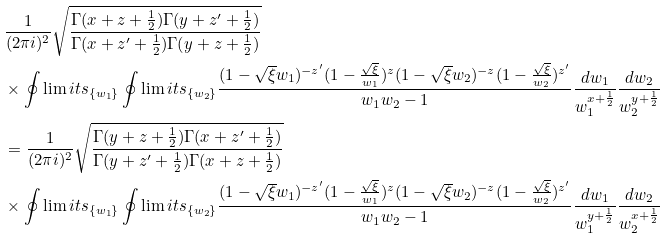Convert formula to latex. <formula><loc_0><loc_0><loc_500><loc_500>& \frac { 1 } { ( 2 \pi i ) ^ { 2 } } \sqrt { \frac { \Gamma ( x + z + \frac { 1 } { 2 } ) \Gamma ( y + z ^ { \prime } + \frac { 1 } { 2 } ) } { \Gamma ( x + z ^ { \prime } + \frac { 1 } { 2 } ) \Gamma ( y + z + \frac { 1 } { 2 } ) } } \\ & \times \oint \lim i t s _ { \{ w _ { 1 } \} } \oint \lim i t s _ { \{ w _ { 2 } \} } \frac { ( 1 - \sqrt { \xi } w _ { 1 } ) ^ { - z ^ { \prime } } ( 1 - \frac { \sqrt { \xi } } { w _ { 1 } } ) ^ { z } ( 1 - \sqrt { \xi } w _ { 2 } ) ^ { - z } ( 1 - \frac { \sqrt { \xi } } { w _ { 2 } } ) ^ { z ^ { \prime } } } { w _ { 1 } w _ { 2 } - 1 } \frac { d w _ { 1 } } { w _ { 1 } ^ { x + \frac { 1 } { 2 } } } \frac { d w _ { 2 } } { w _ { 2 } ^ { y + \frac { 1 } { 2 } } } \\ & = \frac { 1 } { ( 2 \pi i ) ^ { 2 } } \sqrt { \frac { \Gamma ( y + z + \frac { 1 } { 2 } ) \Gamma ( x + z ^ { \prime } + \frac { 1 } { 2 } ) } { \Gamma ( y + z ^ { \prime } + \frac { 1 } { 2 } ) \Gamma ( x + z + \frac { 1 } { 2 } ) } } \\ & \times \oint \lim i t s _ { \{ w _ { 1 } \} } \oint \lim i t s _ { \{ w _ { 2 } \} } \frac { ( 1 - \sqrt { \xi } w _ { 1 } ) ^ { - z ^ { \prime } } ( 1 - \frac { \sqrt { \xi } } { w _ { 1 } } ) ^ { z } ( 1 - \sqrt { \xi } w _ { 2 } ) ^ { - z } ( 1 - \frac { \sqrt { \xi } } { w _ { 2 } } ) ^ { z ^ { \prime } } } { w _ { 1 } w _ { 2 } - 1 } \frac { d w _ { 1 } } { w _ { 1 } ^ { y + \frac { 1 } { 2 } } } \frac { d w _ { 2 } } { w _ { 2 } ^ { x + \frac { 1 } { 2 } } }</formula> 